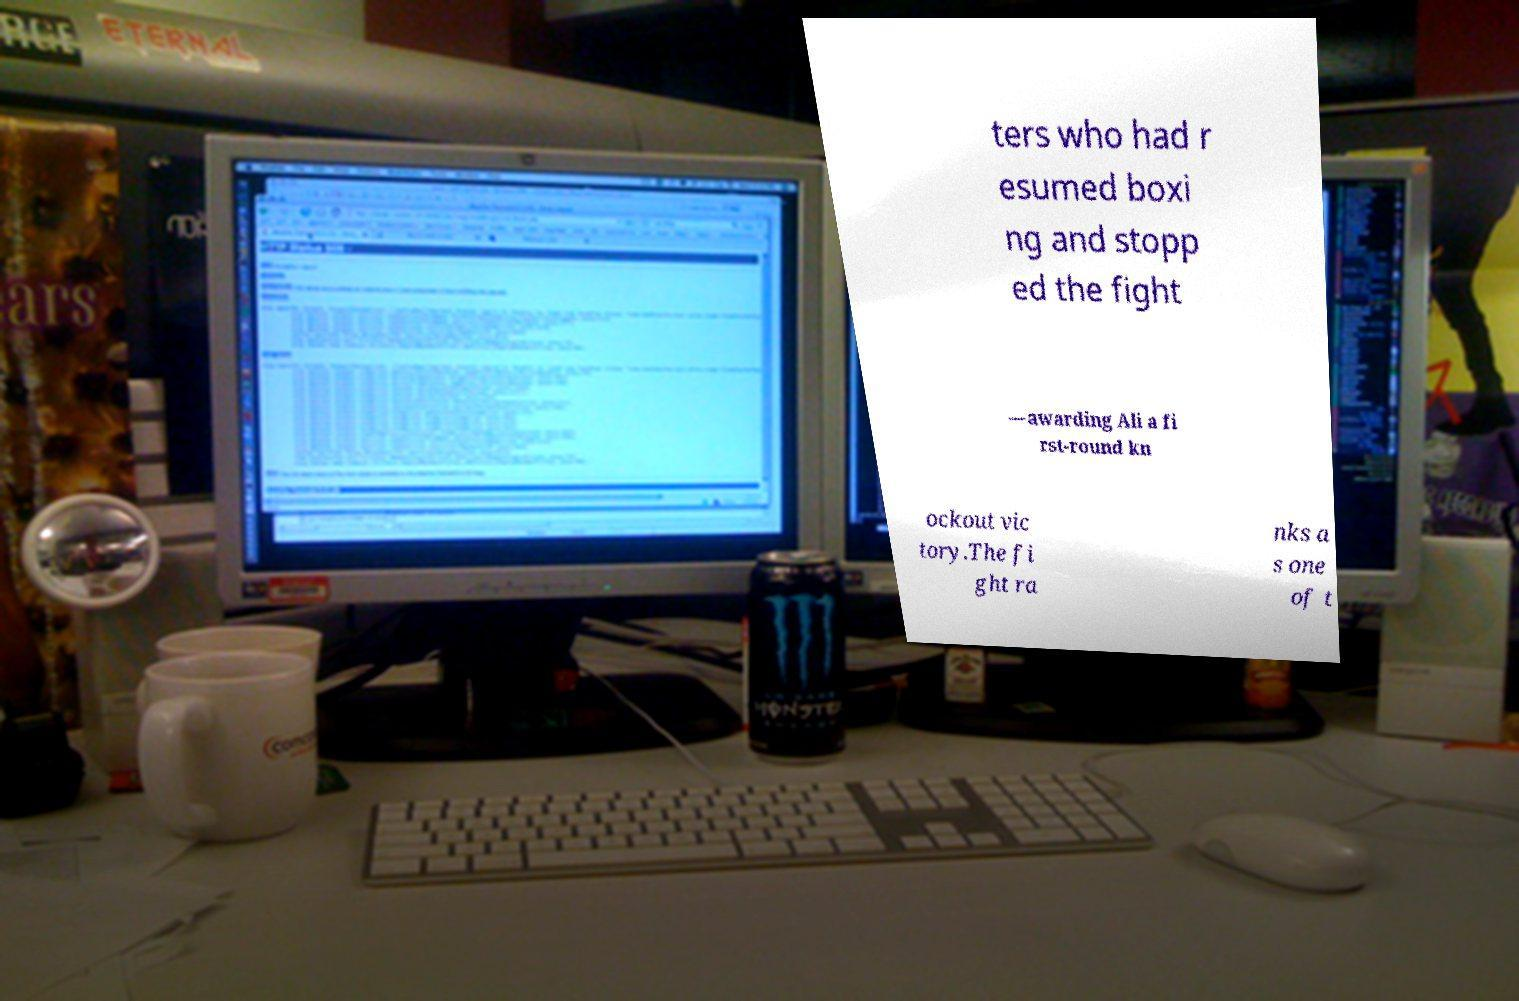Could you extract and type out the text from this image? ters who had r esumed boxi ng and stopp ed the fight —awarding Ali a fi rst-round kn ockout vic tory.The fi ght ra nks a s one of t 